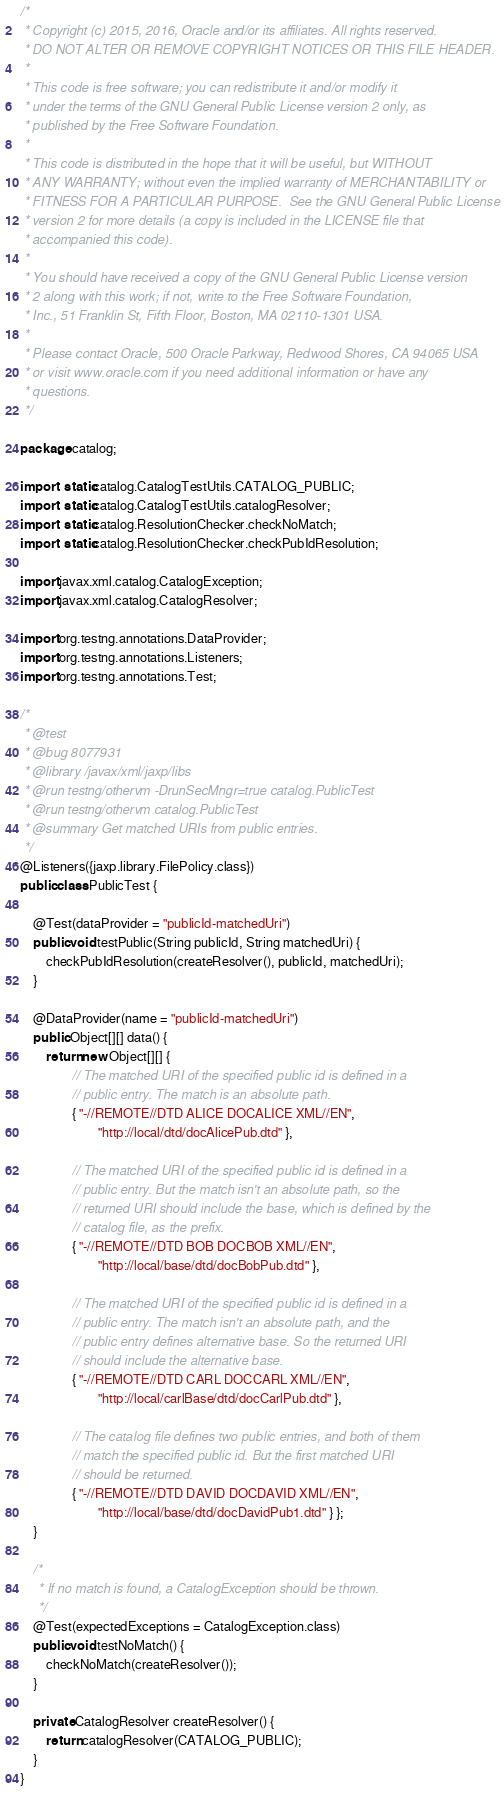<code> <loc_0><loc_0><loc_500><loc_500><_Java_>/*
 * Copyright (c) 2015, 2016, Oracle and/or its affiliates. All rights reserved.
 * DO NOT ALTER OR REMOVE COPYRIGHT NOTICES OR THIS FILE HEADER.
 *
 * This code is free software; you can redistribute it and/or modify it
 * under the terms of the GNU General Public License version 2 only, as
 * published by the Free Software Foundation.
 *
 * This code is distributed in the hope that it will be useful, but WITHOUT
 * ANY WARRANTY; without even the implied warranty of MERCHANTABILITY or
 * FITNESS FOR A PARTICULAR PURPOSE.  See the GNU General Public License
 * version 2 for more details (a copy is included in the LICENSE file that
 * accompanied this code).
 *
 * You should have received a copy of the GNU General Public License version
 * 2 along with this work; if not, write to the Free Software Foundation,
 * Inc., 51 Franklin St, Fifth Floor, Boston, MA 02110-1301 USA.
 *
 * Please contact Oracle, 500 Oracle Parkway, Redwood Shores, CA 94065 USA
 * or visit www.oracle.com if you need additional information or have any
 * questions.
 */

package catalog;

import static catalog.CatalogTestUtils.CATALOG_PUBLIC;
import static catalog.CatalogTestUtils.catalogResolver;
import static catalog.ResolutionChecker.checkNoMatch;
import static catalog.ResolutionChecker.checkPubIdResolution;

import javax.xml.catalog.CatalogException;
import javax.xml.catalog.CatalogResolver;

import org.testng.annotations.DataProvider;
import org.testng.annotations.Listeners;
import org.testng.annotations.Test;

/*
 * @test
 * @bug 8077931
 * @library /javax/xml/jaxp/libs
 * @run testng/othervm -DrunSecMngr=true catalog.PublicTest
 * @run testng/othervm catalog.PublicTest
 * @summary Get matched URIs from public entries.
 */
@Listeners({jaxp.library.FilePolicy.class})
public class PublicTest {

    @Test(dataProvider = "publicId-matchedUri")
    public void testPublic(String publicId, String matchedUri) {
        checkPubIdResolution(createResolver(), publicId, matchedUri);
    }

    @DataProvider(name = "publicId-matchedUri")
    public Object[][] data() {
        return new Object[][] {
                // The matched URI of the specified public id is defined in a
                // public entry. The match is an absolute path.
                { "-//REMOTE//DTD ALICE DOCALICE XML//EN",
                        "http://local/dtd/docAlicePub.dtd" },

                // The matched URI of the specified public id is defined in a
                // public entry. But the match isn't an absolute path, so the
                // returned URI should include the base, which is defined by the
                // catalog file, as the prefix.
                { "-//REMOTE//DTD BOB DOCBOB XML//EN",
                        "http://local/base/dtd/docBobPub.dtd" },

                // The matched URI of the specified public id is defined in a
                // public entry. The match isn't an absolute path, and the
                // public entry defines alternative base. So the returned URI
                // should include the alternative base.
                { "-//REMOTE//DTD CARL DOCCARL XML//EN",
                        "http://local/carlBase/dtd/docCarlPub.dtd" },

                // The catalog file defines two public entries, and both of them
                // match the specified public id. But the first matched URI
                // should be returned.
                { "-//REMOTE//DTD DAVID DOCDAVID XML//EN",
                        "http://local/base/dtd/docDavidPub1.dtd" } };
    }

    /*
     * If no match is found, a CatalogException should be thrown.
     */
    @Test(expectedExceptions = CatalogException.class)
    public void testNoMatch() {
        checkNoMatch(createResolver());
    }

    private CatalogResolver createResolver() {
        return catalogResolver(CATALOG_PUBLIC);
    }
}
</code> 